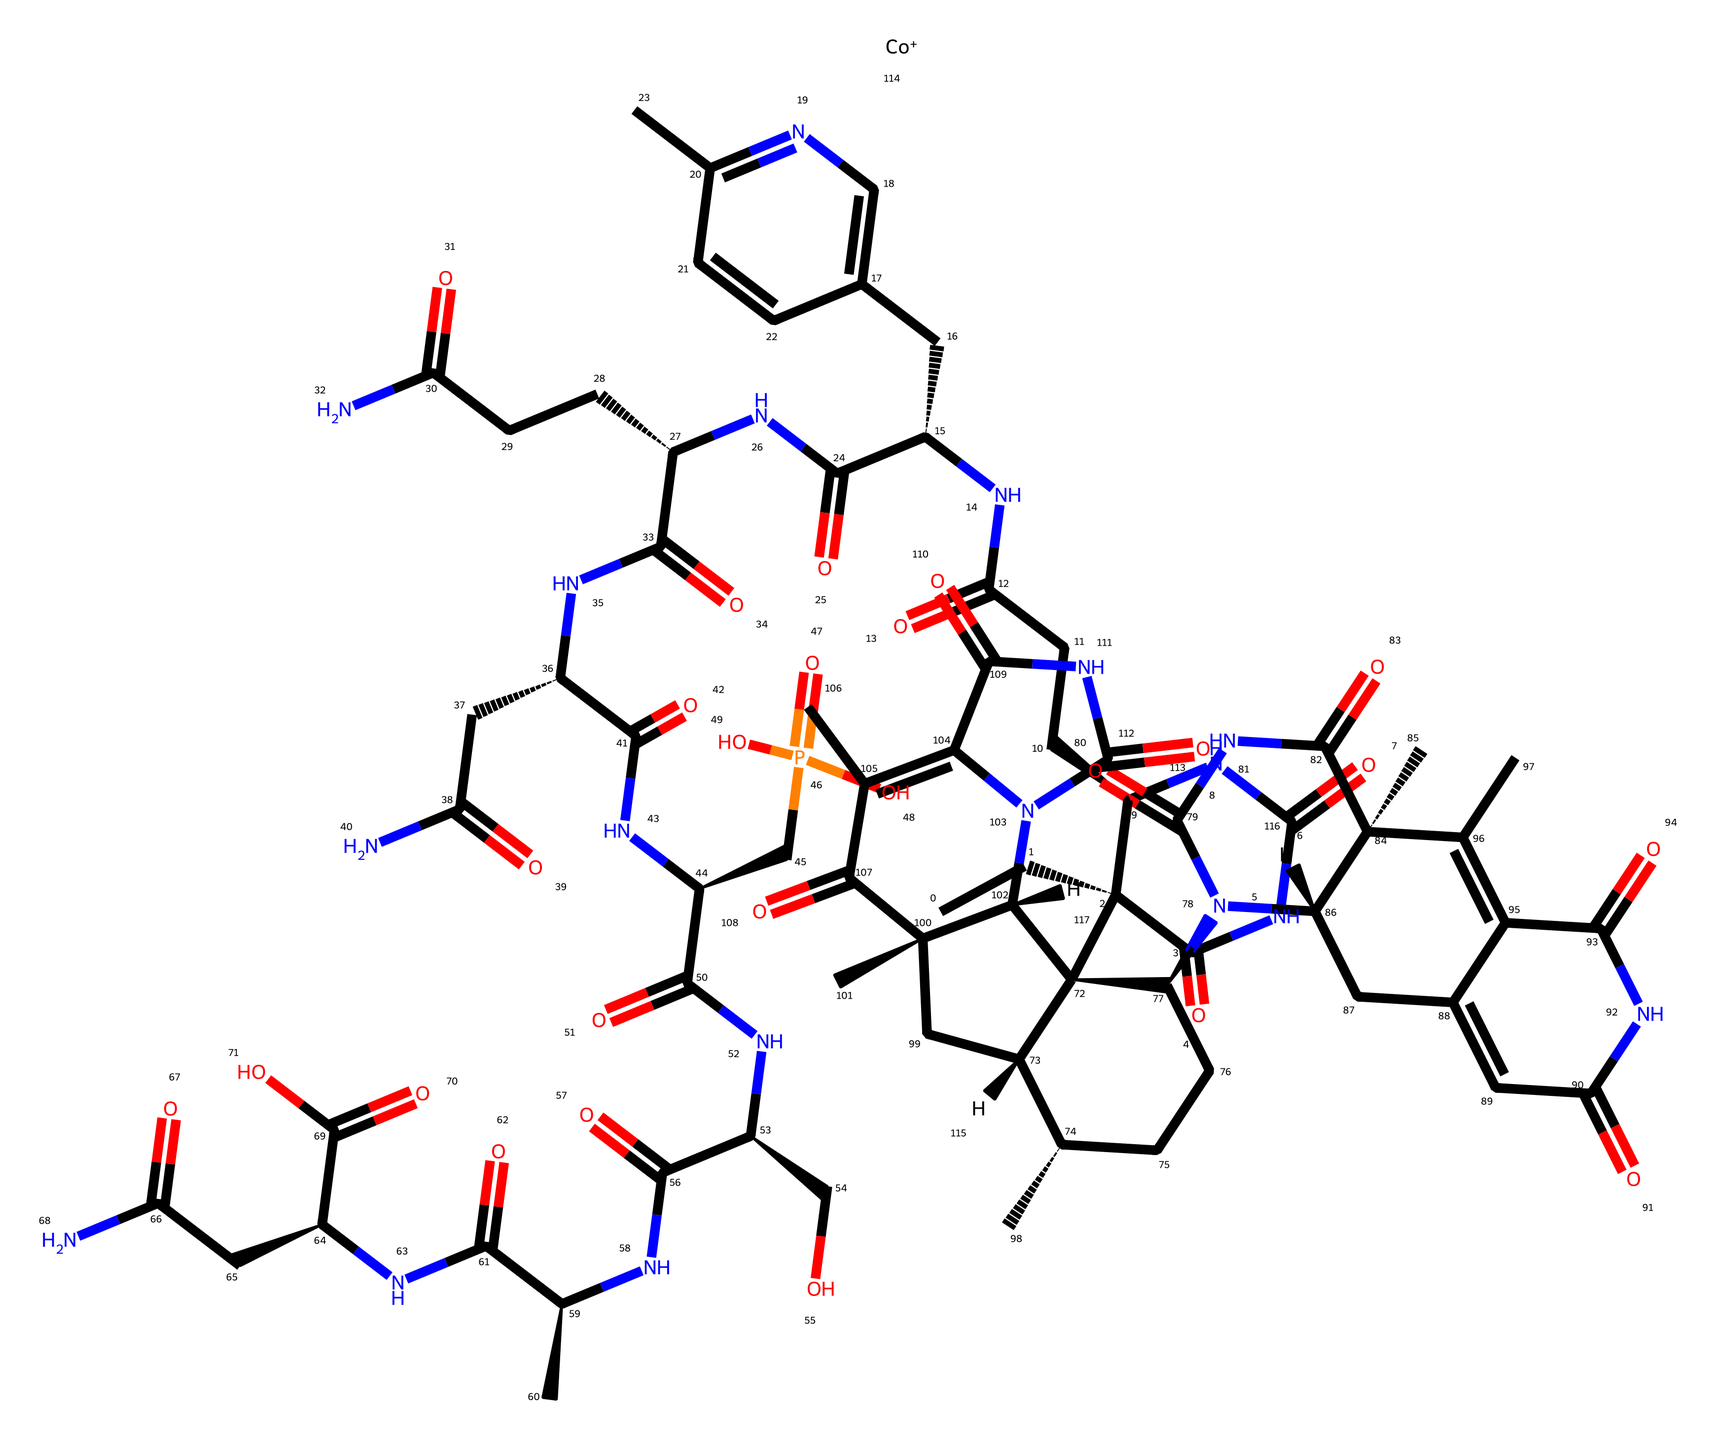How many carbon atoms are present in methylcobalamin? By analyzing the SMILES representation, we identify each "C" which denotes carbon atoms. Counting all the "C" symbols in the structure yields a total of 27 carbon atoms.
Answer: 27 What is the central metal ion in methylcobalamin? The presence of "Co" indicates cobalt. In organometallic compounds, the central metal ion is crucial, and here, cobalt is clearly represented in the SMILES.
Answer: cobalt How many nitrogen atoms are in methylcobalamin? Each "N" in the SMILES denotes a nitrogen atom. Upon counting, there are 6 instances of "N" in the structure, which indicates there are 6 nitrogen atoms.
Answer: 6 Which functional group is represented by "C(=O)"? The notation "C(=O)" represents a carbonyl group, which is characteristic of ketones and aldehydes. In methylcobalamin, this part connects with the overall structure and signifies the presence of various amide and carboxylic functionalities.
Answer: carbonyl group How many rings are present in the structure of methylcobalamin? The presence of numeric digits in the SMILES (like "1", "2", "3", etc.) indicates ring closures. By analyzing the structure, we can identify that there are a total of 2 distinct rings.
Answer: 2 What type of organometallic compound is methylcobalamin classified as? Methylcobalamin can be defined as a coordination compound due to the central cobalt ion coordinating with organic groups such as the ribose and cyanide functionalities. This classification is inherent to its organometallic nature.
Answer: coordination compound What is the significance of the "P(=O)(O)O" part in the structure? The "P(=O)(O)O" section represents a phosphate group, which plays a significant role in biological organisms, including energy transfer and metabolism. In methylcobalamin, it also contributes to biological activity and function.
Answer: phosphate group 